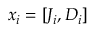Convert formula to latex. <formula><loc_0><loc_0><loc_500><loc_500>x _ { i } = [ J _ { i } , D _ { i } ]</formula> 